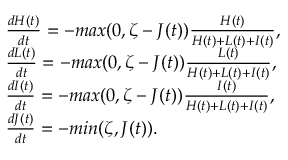Convert formula to latex. <formula><loc_0><loc_0><loc_500><loc_500>\begin{array} { l } { \frac { d H ( t ) } { d t } = - \max ( 0 , \zeta - J ( t ) ) \frac { H ( t ) } { H ( t ) + L ( t ) + I ( t ) } , } \\ { \frac { d L ( t ) } { d t } = - \max ( 0 , \zeta - J ( t ) ) \frac { L ( t ) } { H ( t ) + L ( t ) + I ( t ) } , } \\ { \frac { d I ( t ) } { d t } = - \max ( 0 , \zeta - J ( t ) ) \frac { I ( t ) } { H ( t ) + L ( t ) + I ( t ) } , } \\ { \frac { d J ( t ) } { d t } = - \min ( \zeta , J ( t ) ) . } \end{array}</formula> 